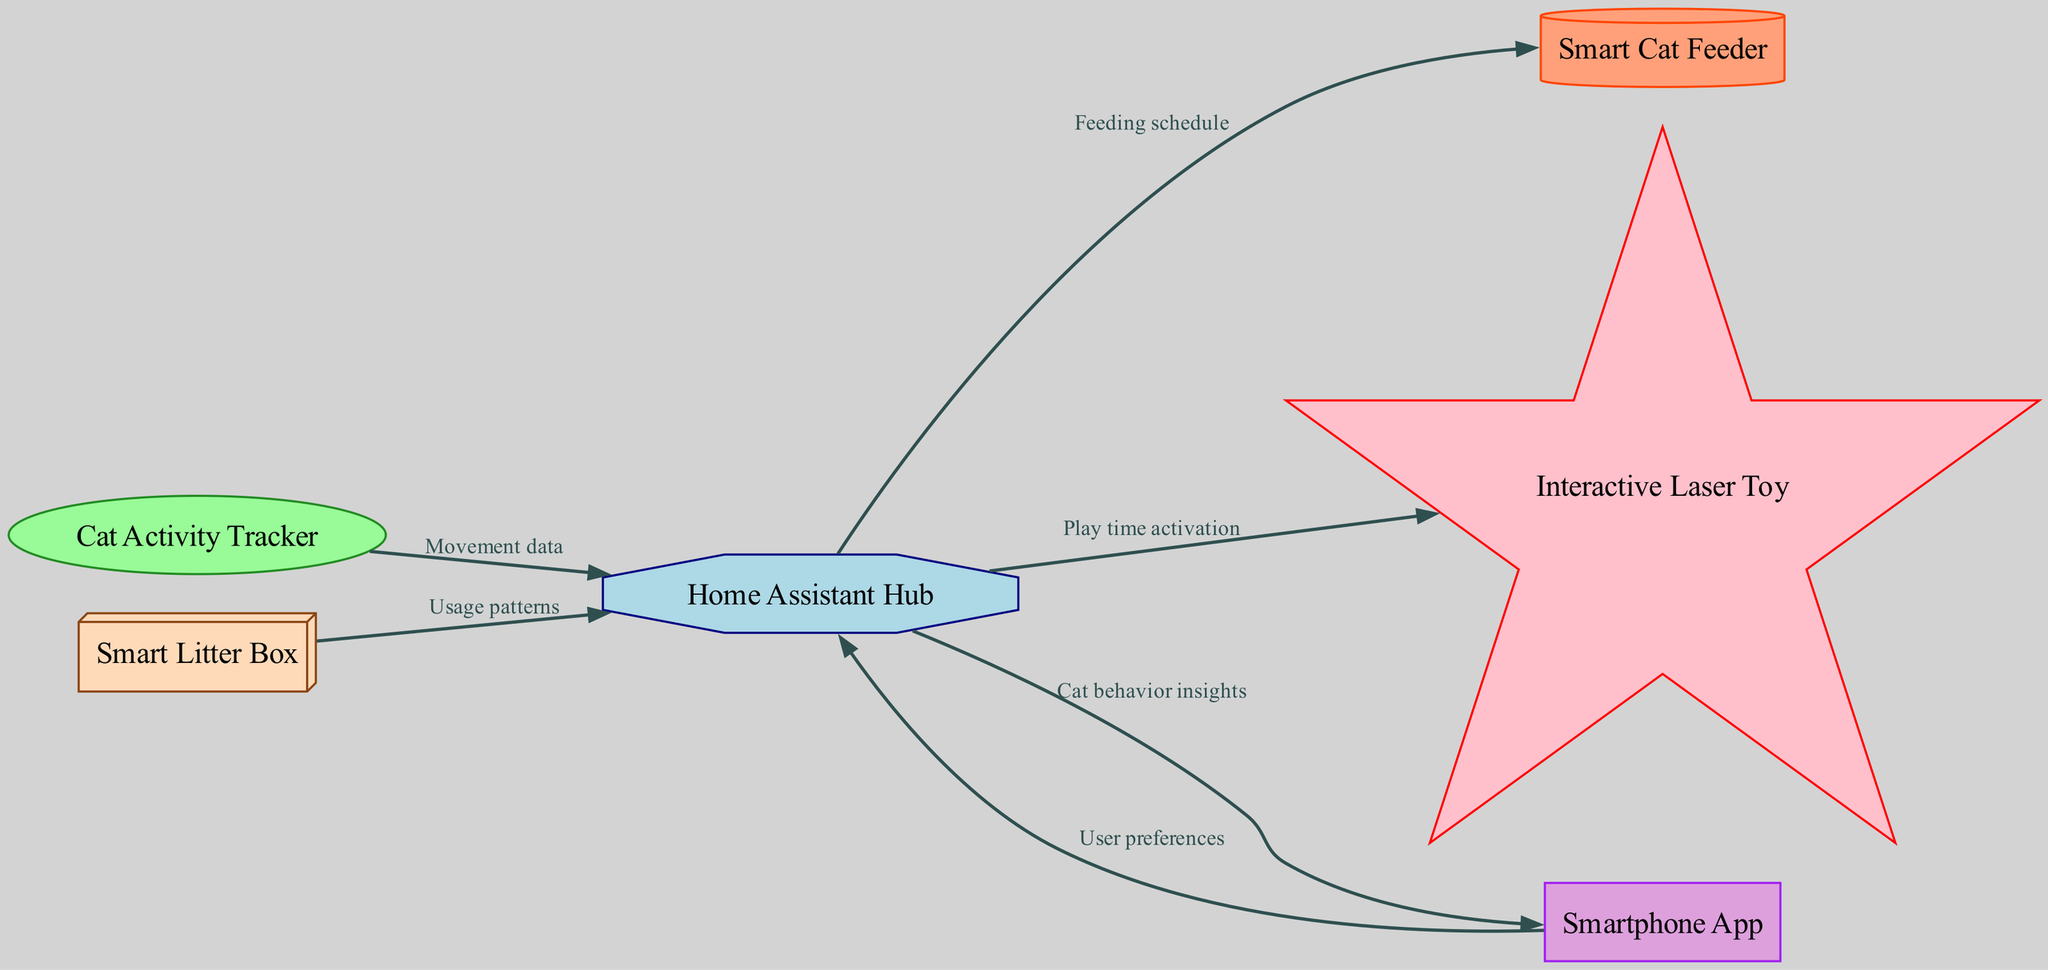What are the main entities in the diagram? The diagram displays six entities: Smart Cat Feeder, Cat Activity Tracker, Interactive Laser Toy, Smart Litter Box, Home Assistant Hub, and Smartphone App. These represent the various components involved in the cat-friendly smart home system.
Answer: Smart Cat Feeder, Cat Activity Tracker, Interactive Laser Toy, Smart Litter Box, Home Assistant Hub, Smartphone App How many data flows are shown between the entities? The diagram illustrates five data flows that connect the different entities. Each flow represents the transfer of specific information from one component to another in the smart home system.
Answer: Five What data does the Cat Activity Tracker send to the Home Assistant Hub? The Cat Activity Tracker transmits movement data to the Home Assistant Hub, indicating the activity level or behavior of the cat.
Answer: Movement data What type of device is the Home Assistant Hub? In the diagram, the Home Assistant Hub is represented as an octagon, which signifies its central role in receiving and processing data from other devices in the system.
Answer: Octagon Which device receives the feeding schedule from the Home Assistant Hub? According to the diagram, the Smart Cat Feeder receives the feeding schedule from the Home Assistant Hub, allowing it to dispense food according to the specified times.
Answer: Smart Cat Feeder If the user sets preferences in the Smartphone App, which entity is affected? When the user inputs their preferences in the Smartphone App, these preferences are sent to the Home Assistant Hub, which can adjust its operations accordingly.
Answer: Home Assistant Hub What type of information does the Smart Litter Box provide to the Home Assistant Hub? The Smart Litter Box contributes usage patterns to the Home Assistant Hub, which could include frequency of use or behavioral changes related to litter box habits.
Answer: Usage patterns How does the Home Assistant Hub communicate play time to the Interactive Laser Toy? The Home Assistant Hub sends a play time activation signal to the Interactive Laser Toy, initiating play sessions to keep the cat entertained.
Answer: Play time activation 